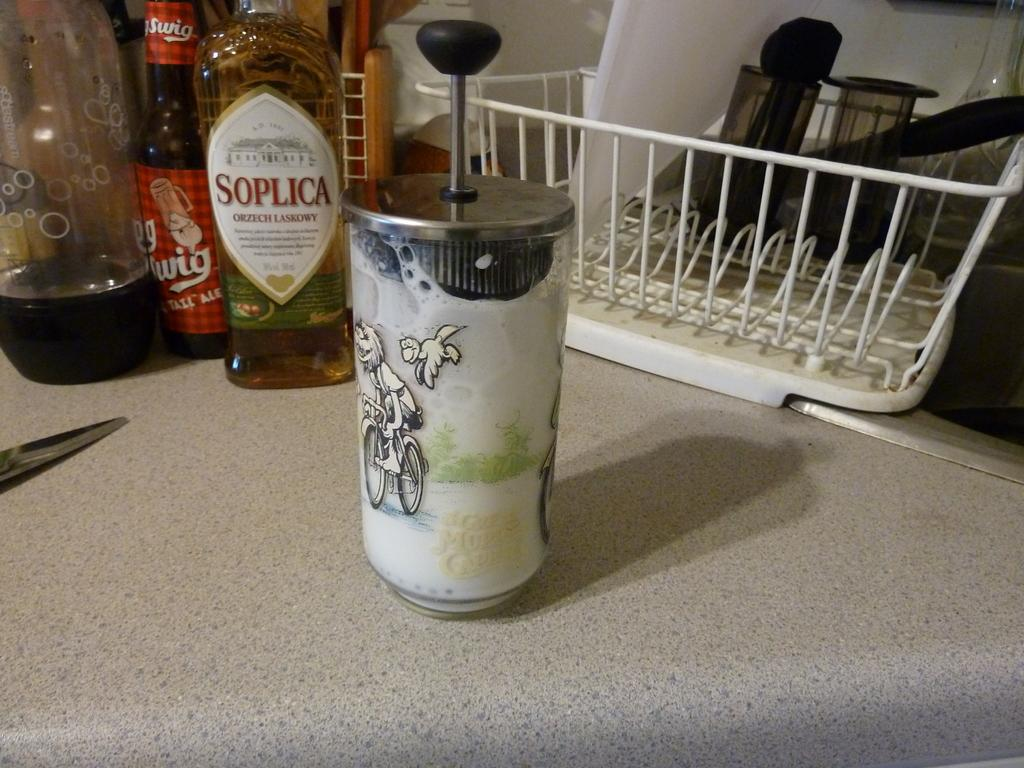<image>
Render a clear and concise summary of the photo. A bottle of Soplica next to red bottle in a kitchen. 